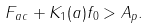<formula> <loc_0><loc_0><loc_500><loc_500>F _ { a c } + K _ { 1 } ( a ) f _ { 0 } > A _ { p } .</formula> 